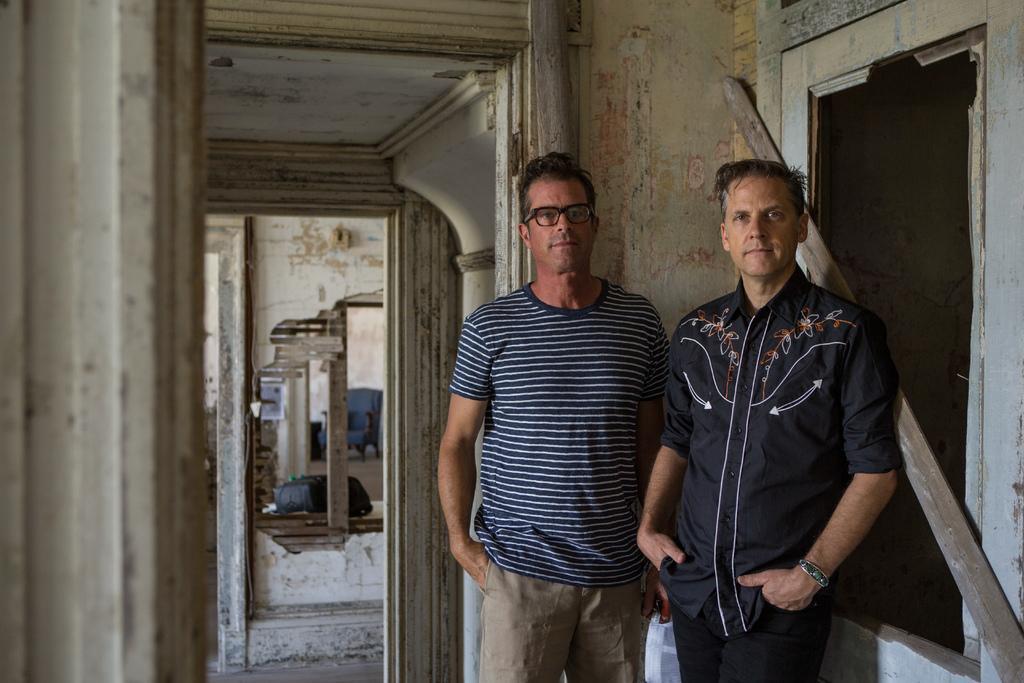How would you summarize this image in a sentence or two? In this picture we can observe two men standing on the floor. One of them is wearing a T shirt and spectacles. Behind them there is a wall. On the right side we can observe a window. In the background we can observe a blue color chair and a wall. 